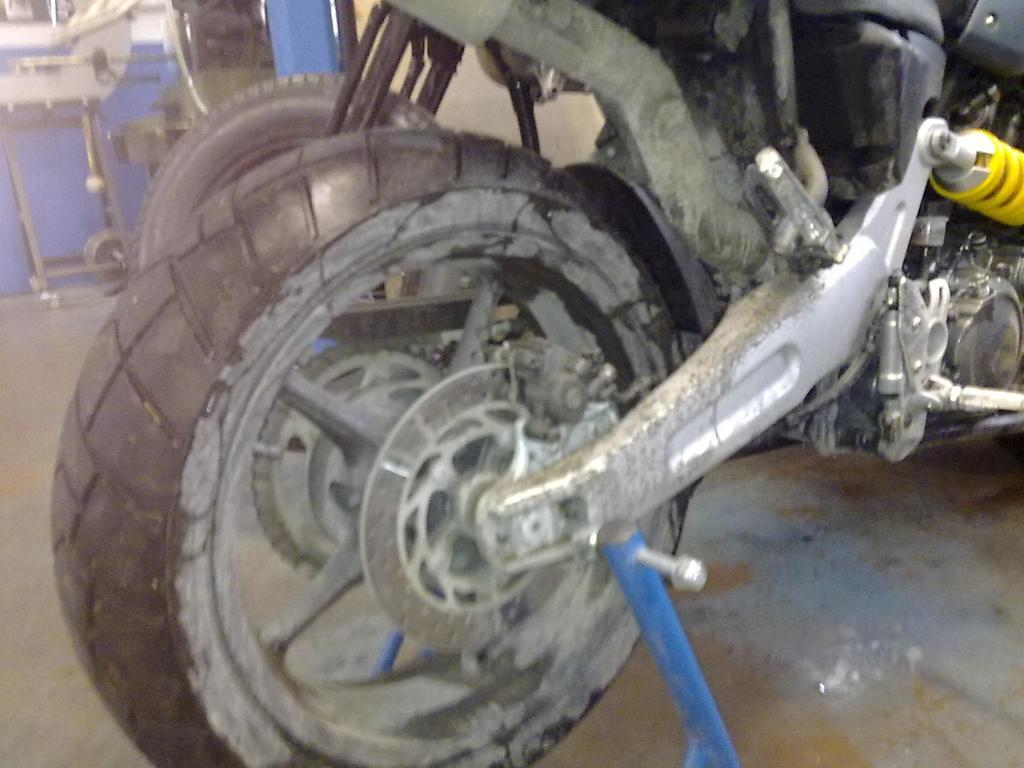What object can be seen in the image? There is a tire in the image. To which type of vehicle does the tire belong? The tire belongs to a vehicle. Where is the tire located in the image? The tire is placed on the road. Can you see a dog playing with a rock in space in the image? No, there is no dog, rock, or space depicted in the image; it only features a tire placed on the road. 